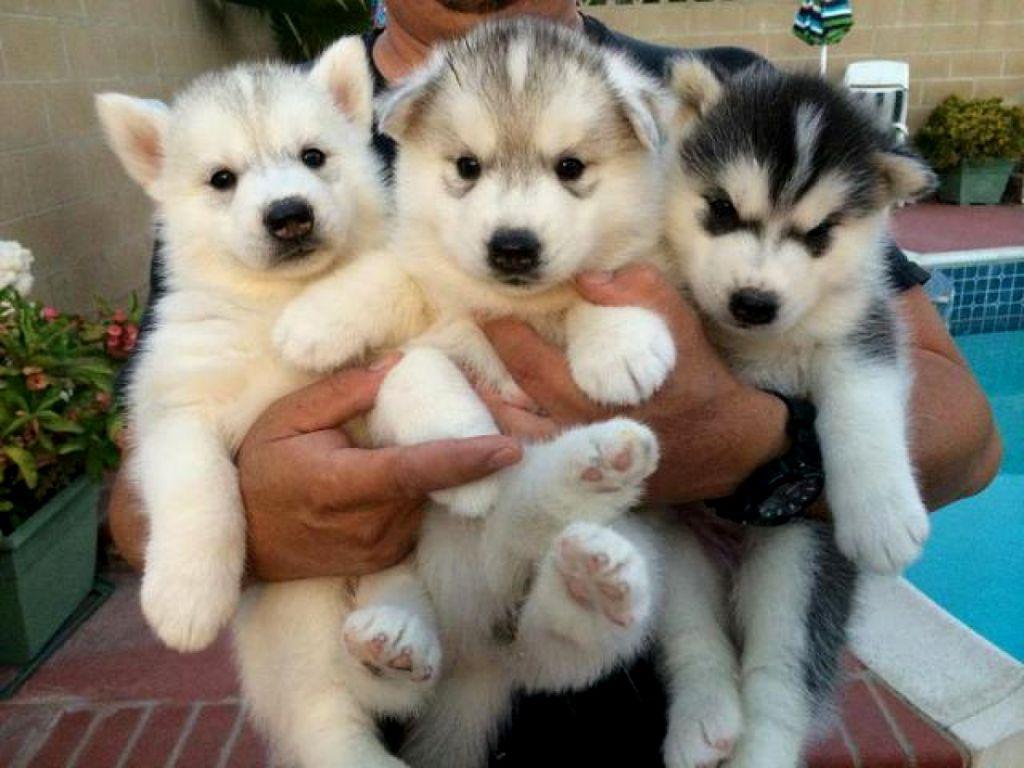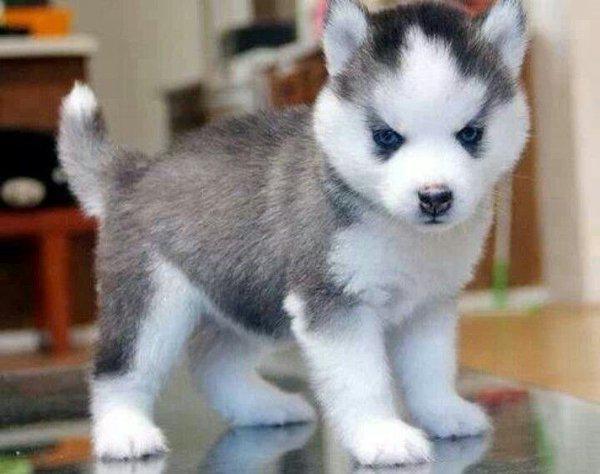The first image is the image on the left, the second image is the image on the right. Assess this claim about the two images: "At least one dog has its mouth open.". Correct or not? Answer yes or no. No. The first image is the image on the left, the second image is the image on the right. Assess this claim about the two images: "There are less than 5 dogs.". Correct or not? Answer yes or no. Yes. 